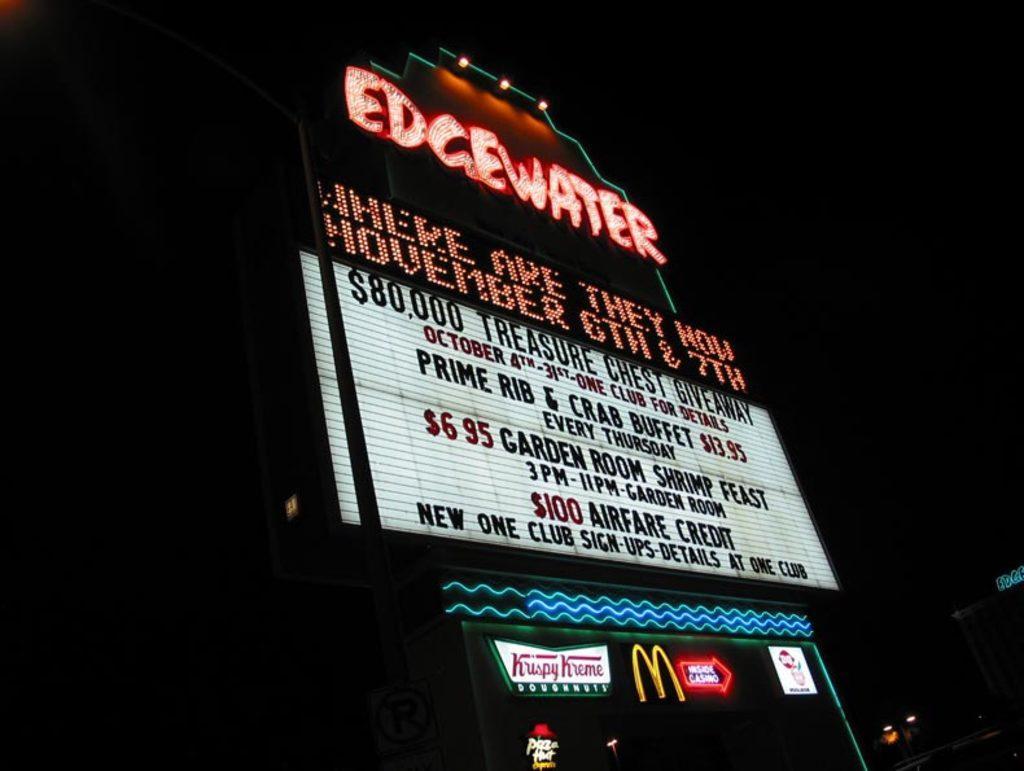Could you give a brief overview of what you see in this image? As we can see in the image there is a building, banners and there is some matter written over here. The image is dark. 